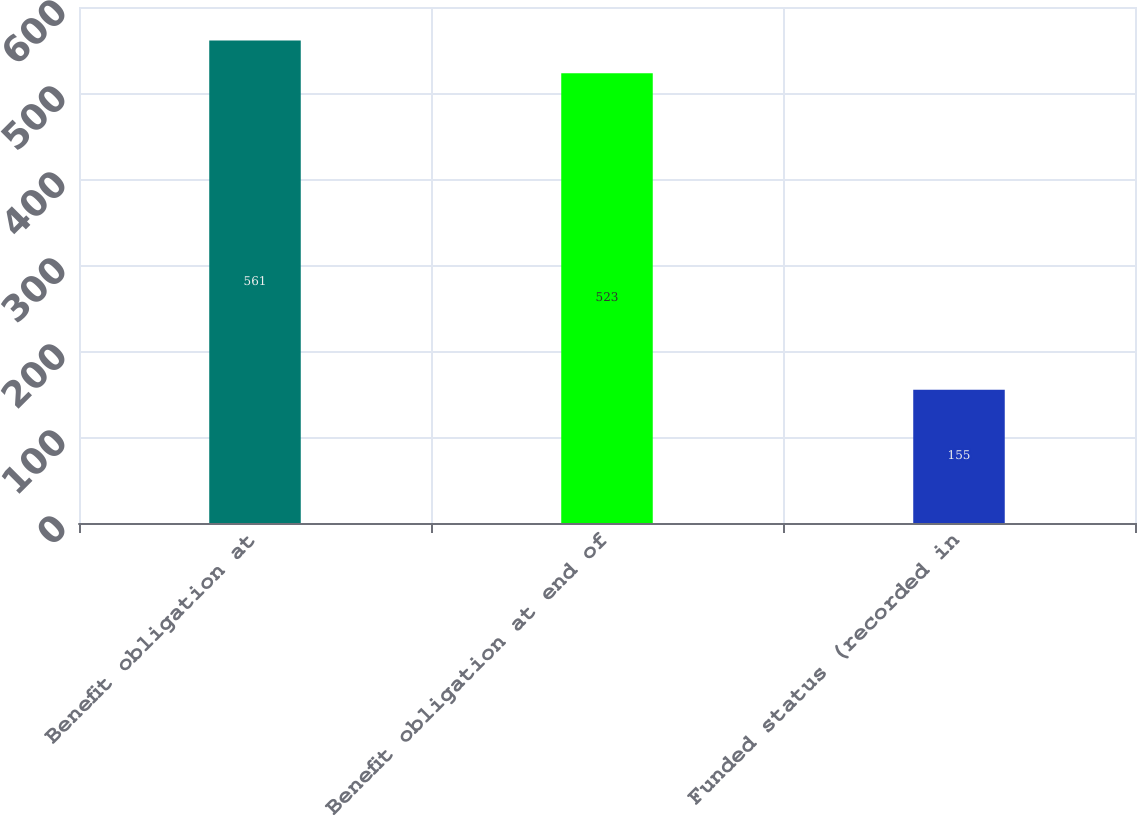Convert chart to OTSL. <chart><loc_0><loc_0><loc_500><loc_500><bar_chart><fcel>Benefit obligation at<fcel>Benefit obligation at end of<fcel>Funded status (recorded in<nl><fcel>561<fcel>523<fcel>155<nl></chart> 